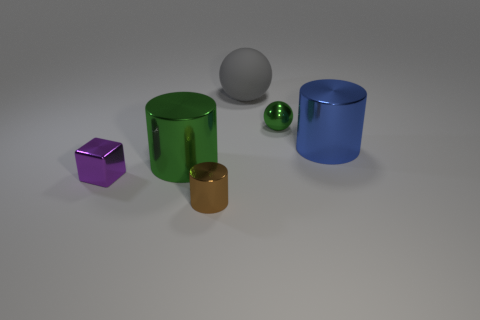Are the objects made of the same material or different, and how can you tell? The objects appear to have different materials — their surfaces reflect light differently. For instance, the purple and brown objects have matte surfaces suggesting a non-reflective material, whereas the green and blue objects exhibit shiny surfaces, indicating a more reflective material like plastic or polished metal. 